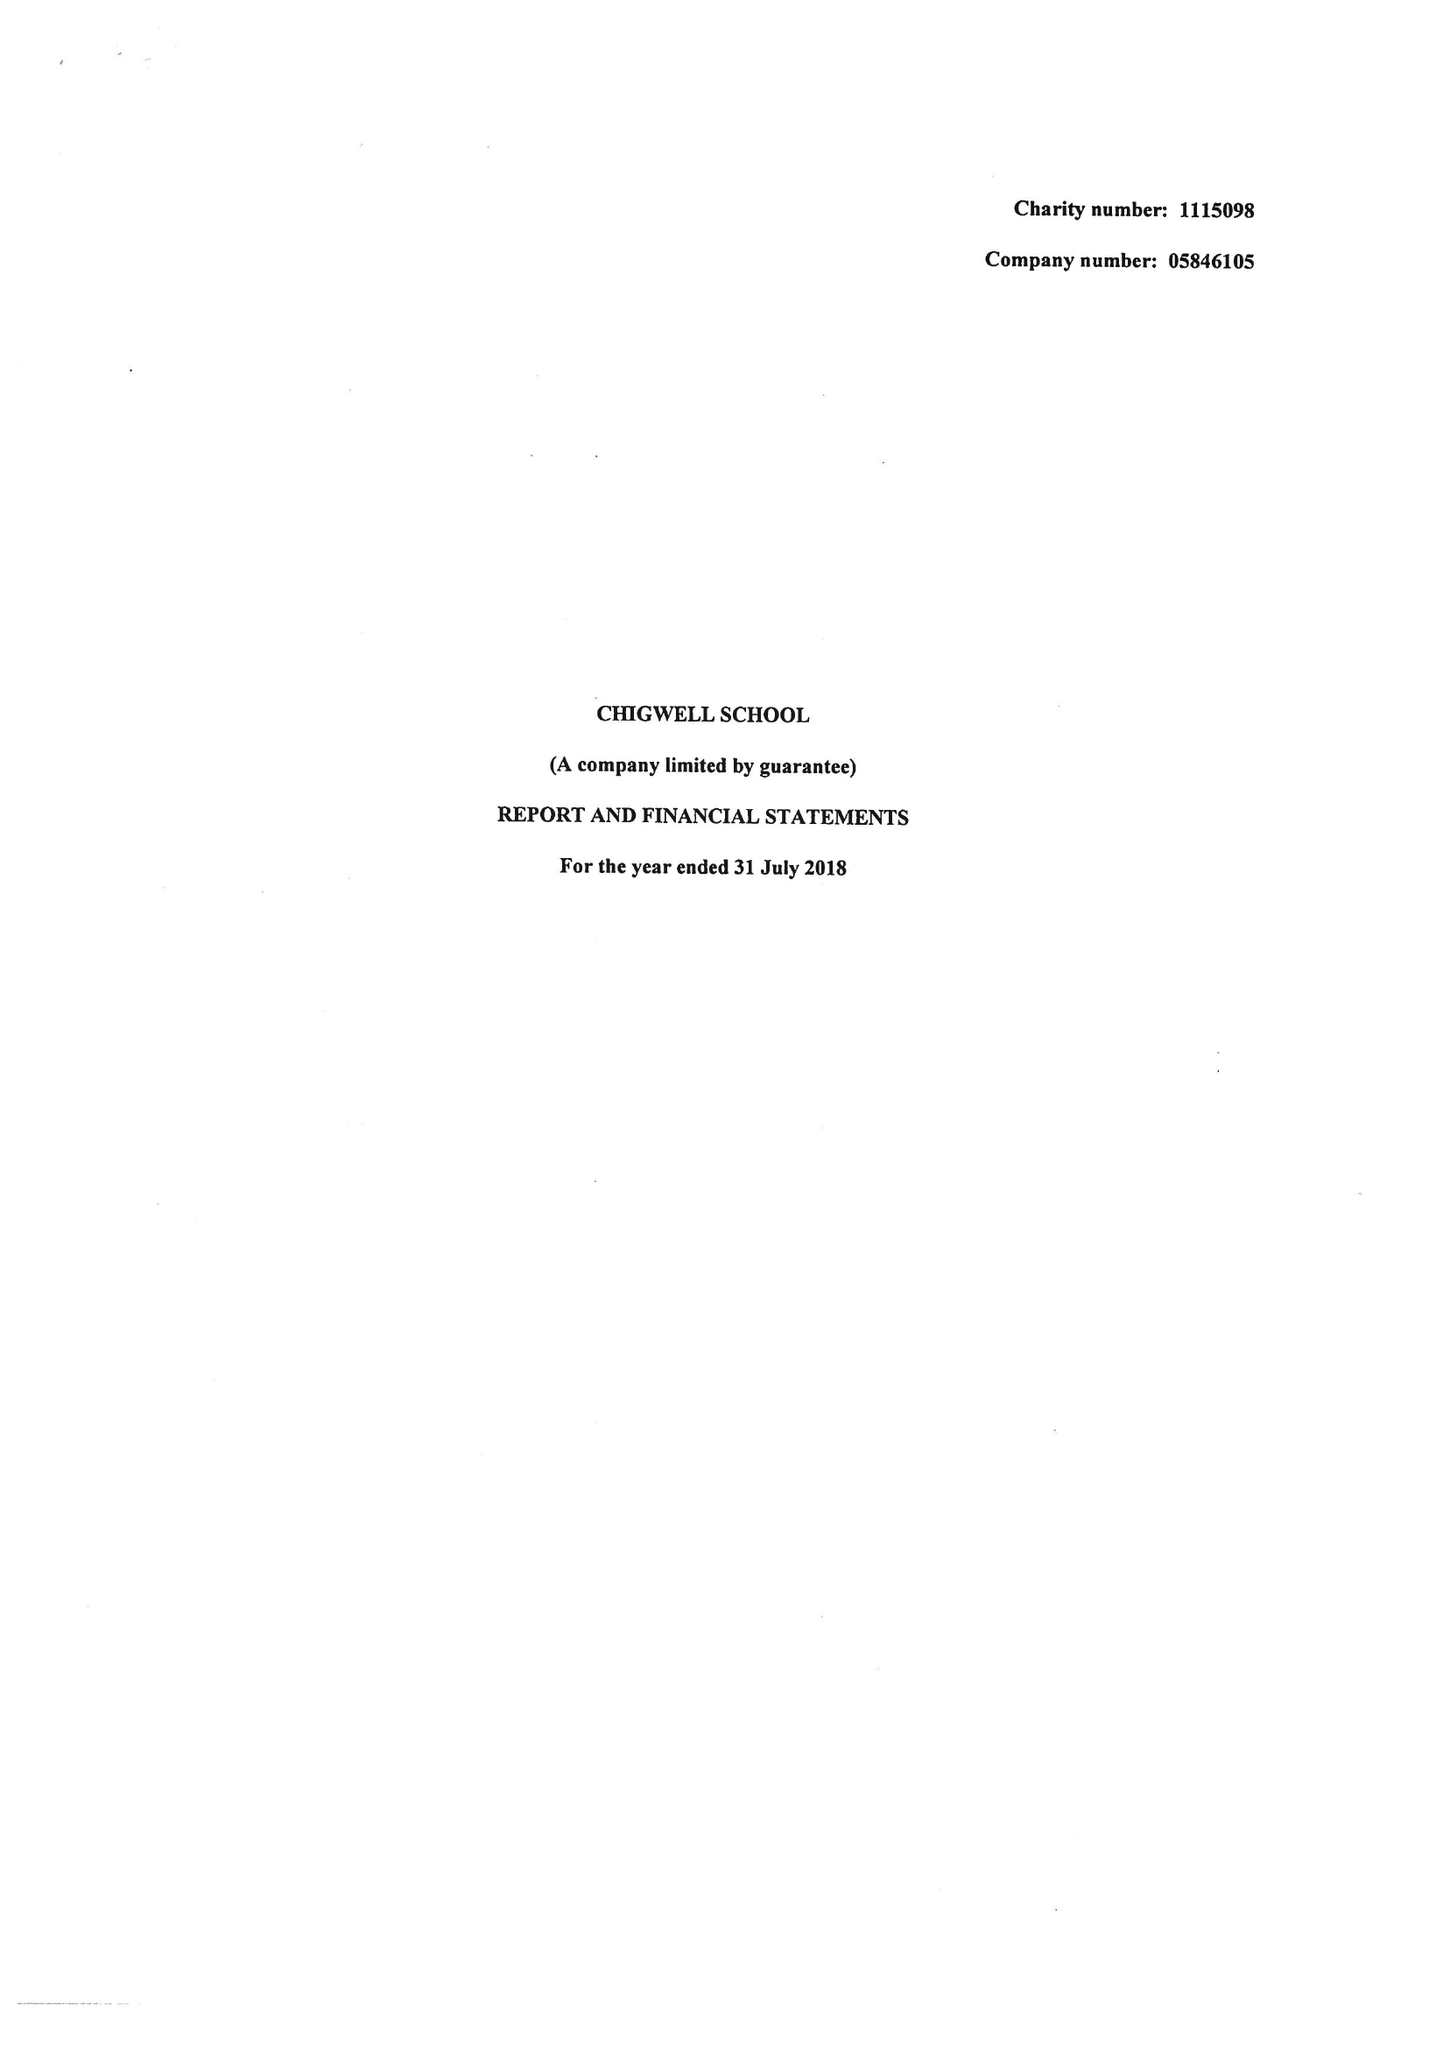What is the value for the address__street_line?
Answer the question using a single word or phrase. HIGH ROAD 